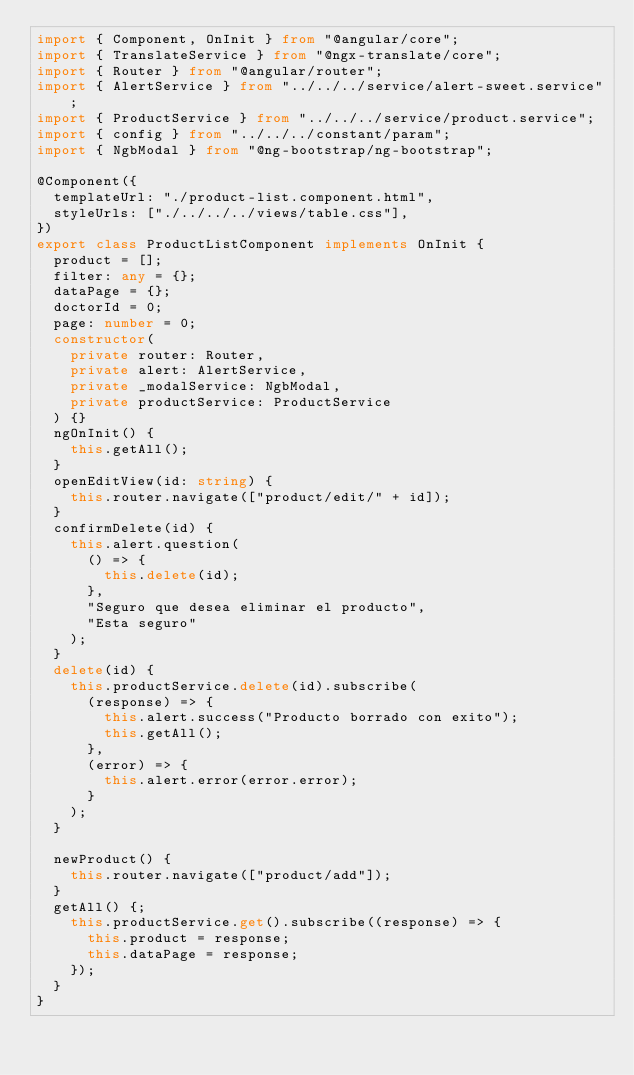<code> <loc_0><loc_0><loc_500><loc_500><_TypeScript_>import { Component, OnInit } from "@angular/core";
import { TranslateService } from "@ngx-translate/core";
import { Router } from "@angular/router";
import { AlertService } from "../../../service/alert-sweet.service";
import { ProductService } from "../../../service/product.service";
import { config } from "../../../constant/param";
import { NgbModal } from "@ng-bootstrap/ng-bootstrap";

@Component({
  templateUrl: "./product-list.component.html",
  styleUrls: ["./../../../views/table.css"],
})
export class ProductListComponent implements OnInit {
  product = [];
  filter: any = {};
  dataPage = {};
  doctorId = 0;
  page: number = 0;
  constructor(
    private router: Router,
    private alert: AlertService,
    private _modalService: NgbModal,
    private productService: ProductService
  ) {}
  ngOnInit() {
    this.getAll();
  }
  openEditView(id: string) {
    this.router.navigate(["product/edit/" + id]);
  }
  confirmDelete(id) {
    this.alert.question(
      () => {
        this.delete(id);
      },
      "Seguro que desea eliminar el producto",
      "Esta seguro"
    );
  }
  delete(id) {
    this.productService.delete(id).subscribe(
      (response) => {
        this.alert.success("Producto borrado con exito");
        this.getAll();
      },
      (error) => {
        this.alert.error(error.error);
      }
    );
  }

  newProduct() {
    this.router.navigate(["product/add"]);
  }
  getAll() {;
    this.productService.get().subscribe((response) => {
      this.product = response;
      this.dataPage = response;
    });
  }
}
</code> 